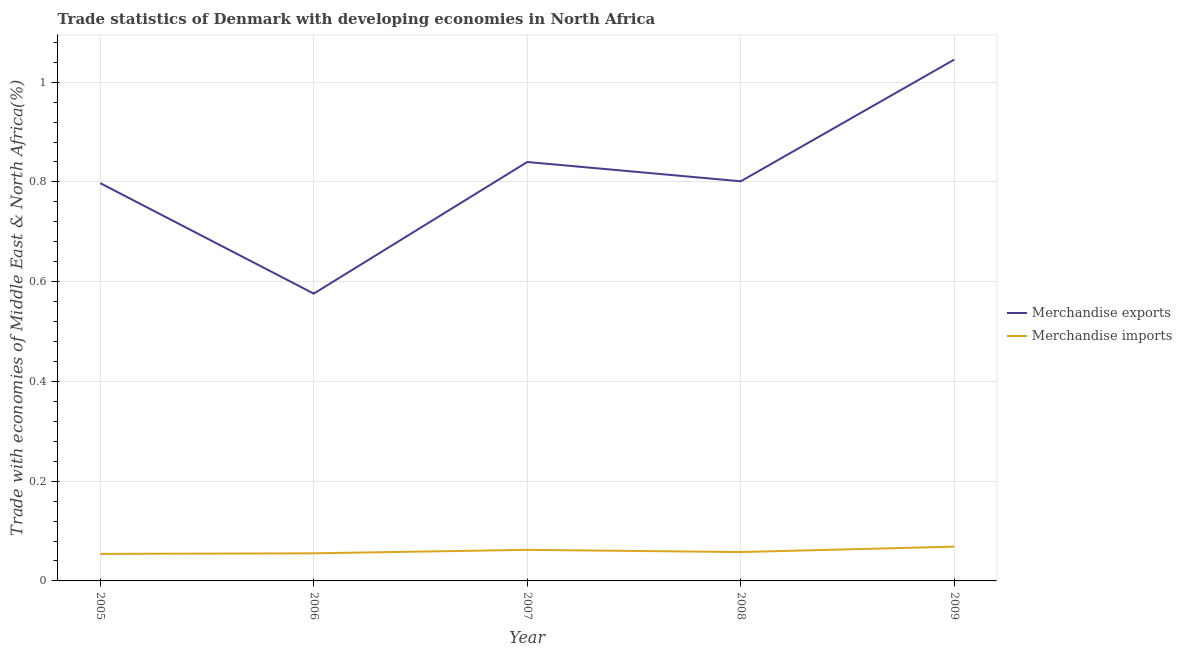Is the number of lines equal to the number of legend labels?
Offer a terse response. Yes. What is the merchandise exports in 2008?
Offer a very short reply. 0.8. Across all years, what is the maximum merchandise imports?
Give a very brief answer. 0.07. Across all years, what is the minimum merchandise imports?
Ensure brevity in your answer.  0.05. In which year was the merchandise imports minimum?
Keep it short and to the point. 2005. What is the total merchandise exports in the graph?
Keep it short and to the point. 4.06. What is the difference between the merchandise exports in 2007 and that in 2008?
Offer a very short reply. 0.04. What is the difference between the merchandise imports in 2007 and the merchandise exports in 2006?
Provide a succinct answer. -0.51. What is the average merchandise imports per year?
Offer a terse response. 0.06. In the year 2008, what is the difference between the merchandise exports and merchandise imports?
Provide a succinct answer. 0.74. In how many years, is the merchandise imports greater than 0.48000000000000004 %?
Give a very brief answer. 0. What is the ratio of the merchandise exports in 2006 to that in 2008?
Keep it short and to the point. 0.72. Is the merchandise exports in 2006 less than that in 2009?
Keep it short and to the point. Yes. Is the difference between the merchandise exports in 2005 and 2006 greater than the difference between the merchandise imports in 2005 and 2006?
Provide a succinct answer. Yes. What is the difference between the highest and the second highest merchandise exports?
Provide a short and direct response. 0.21. What is the difference between the highest and the lowest merchandise imports?
Your answer should be compact. 0.01. In how many years, is the merchandise imports greater than the average merchandise imports taken over all years?
Your answer should be compact. 2. Is the sum of the merchandise imports in 2007 and 2009 greater than the maximum merchandise exports across all years?
Keep it short and to the point. No. Is the merchandise imports strictly less than the merchandise exports over the years?
Your response must be concise. Yes. How many years are there in the graph?
Provide a succinct answer. 5. What is the difference between two consecutive major ticks on the Y-axis?
Provide a short and direct response. 0.2. What is the title of the graph?
Ensure brevity in your answer.  Trade statistics of Denmark with developing economies in North Africa. What is the label or title of the X-axis?
Offer a very short reply. Year. What is the label or title of the Y-axis?
Your response must be concise. Trade with economies of Middle East & North Africa(%). What is the Trade with economies of Middle East & North Africa(%) of Merchandise exports in 2005?
Make the answer very short. 0.8. What is the Trade with economies of Middle East & North Africa(%) of Merchandise imports in 2005?
Your answer should be very brief. 0.05. What is the Trade with economies of Middle East & North Africa(%) in Merchandise exports in 2006?
Provide a short and direct response. 0.58. What is the Trade with economies of Middle East & North Africa(%) in Merchandise imports in 2006?
Ensure brevity in your answer.  0.06. What is the Trade with economies of Middle East & North Africa(%) in Merchandise exports in 2007?
Offer a terse response. 0.84. What is the Trade with economies of Middle East & North Africa(%) of Merchandise imports in 2007?
Ensure brevity in your answer.  0.06. What is the Trade with economies of Middle East & North Africa(%) in Merchandise exports in 2008?
Offer a very short reply. 0.8. What is the Trade with economies of Middle East & North Africa(%) of Merchandise imports in 2008?
Provide a succinct answer. 0.06. What is the Trade with economies of Middle East & North Africa(%) in Merchandise exports in 2009?
Give a very brief answer. 1.05. What is the Trade with economies of Middle East & North Africa(%) of Merchandise imports in 2009?
Provide a succinct answer. 0.07. Across all years, what is the maximum Trade with economies of Middle East & North Africa(%) in Merchandise exports?
Offer a very short reply. 1.05. Across all years, what is the maximum Trade with economies of Middle East & North Africa(%) of Merchandise imports?
Your answer should be compact. 0.07. Across all years, what is the minimum Trade with economies of Middle East & North Africa(%) of Merchandise exports?
Give a very brief answer. 0.58. Across all years, what is the minimum Trade with economies of Middle East & North Africa(%) of Merchandise imports?
Give a very brief answer. 0.05. What is the total Trade with economies of Middle East & North Africa(%) of Merchandise exports in the graph?
Provide a succinct answer. 4.06. What is the total Trade with economies of Middle East & North Africa(%) of Merchandise imports in the graph?
Ensure brevity in your answer.  0.3. What is the difference between the Trade with economies of Middle East & North Africa(%) of Merchandise exports in 2005 and that in 2006?
Offer a terse response. 0.22. What is the difference between the Trade with economies of Middle East & North Africa(%) in Merchandise imports in 2005 and that in 2006?
Keep it short and to the point. -0. What is the difference between the Trade with economies of Middle East & North Africa(%) in Merchandise exports in 2005 and that in 2007?
Offer a terse response. -0.04. What is the difference between the Trade with economies of Middle East & North Africa(%) in Merchandise imports in 2005 and that in 2007?
Offer a very short reply. -0.01. What is the difference between the Trade with economies of Middle East & North Africa(%) in Merchandise exports in 2005 and that in 2008?
Your answer should be compact. -0. What is the difference between the Trade with economies of Middle East & North Africa(%) in Merchandise imports in 2005 and that in 2008?
Your answer should be very brief. -0. What is the difference between the Trade with economies of Middle East & North Africa(%) in Merchandise exports in 2005 and that in 2009?
Provide a short and direct response. -0.25. What is the difference between the Trade with economies of Middle East & North Africa(%) of Merchandise imports in 2005 and that in 2009?
Provide a succinct answer. -0.01. What is the difference between the Trade with economies of Middle East & North Africa(%) in Merchandise exports in 2006 and that in 2007?
Ensure brevity in your answer.  -0.26. What is the difference between the Trade with economies of Middle East & North Africa(%) of Merchandise imports in 2006 and that in 2007?
Your response must be concise. -0.01. What is the difference between the Trade with economies of Middle East & North Africa(%) of Merchandise exports in 2006 and that in 2008?
Provide a succinct answer. -0.23. What is the difference between the Trade with economies of Middle East & North Africa(%) in Merchandise imports in 2006 and that in 2008?
Make the answer very short. -0. What is the difference between the Trade with economies of Middle East & North Africa(%) of Merchandise exports in 2006 and that in 2009?
Offer a terse response. -0.47. What is the difference between the Trade with economies of Middle East & North Africa(%) in Merchandise imports in 2006 and that in 2009?
Ensure brevity in your answer.  -0.01. What is the difference between the Trade with economies of Middle East & North Africa(%) of Merchandise exports in 2007 and that in 2008?
Your response must be concise. 0.04. What is the difference between the Trade with economies of Middle East & North Africa(%) of Merchandise imports in 2007 and that in 2008?
Your answer should be very brief. 0. What is the difference between the Trade with economies of Middle East & North Africa(%) of Merchandise exports in 2007 and that in 2009?
Give a very brief answer. -0.21. What is the difference between the Trade with economies of Middle East & North Africa(%) of Merchandise imports in 2007 and that in 2009?
Ensure brevity in your answer.  -0.01. What is the difference between the Trade with economies of Middle East & North Africa(%) of Merchandise exports in 2008 and that in 2009?
Ensure brevity in your answer.  -0.24. What is the difference between the Trade with economies of Middle East & North Africa(%) of Merchandise imports in 2008 and that in 2009?
Offer a terse response. -0.01. What is the difference between the Trade with economies of Middle East & North Africa(%) of Merchandise exports in 2005 and the Trade with economies of Middle East & North Africa(%) of Merchandise imports in 2006?
Ensure brevity in your answer.  0.74. What is the difference between the Trade with economies of Middle East & North Africa(%) in Merchandise exports in 2005 and the Trade with economies of Middle East & North Africa(%) in Merchandise imports in 2007?
Your response must be concise. 0.74. What is the difference between the Trade with economies of Middle East & North Africa(%) in Merchandise exports in 2005 and the Trade with economies of Middle East & North Africa(%) in Merchandise imports in 2008?
Give a very brief answer. 0.74. What is the difference between the Trade with economies of Middle East & North Africa(%) of Merchandise exports in 2005 and the Trade with economies of Middle East & North Africa(%) of Merchandise imports in 2009?
Offer a terse response. 0.73. What is the difference between the Trade with economies of Middle East & North Africa(%) of Merchandise exports in 2006 and the Trade with economies of Middle East & North Africa(%) of Merchandise imports in 2007?
Your answer should be very brief. 0.51. What is the difference between the Trade with economies of Middle East & North Africa(%) of Merchandise exports in 2006 and the Trade with economies of Middle East & North Africa(%) of Merchandise imports in 2008?
Offer a terse response. 0.52. What is the difference between the Trade with economies of Middle East & North Africa(%) of Merchandise exports in 2006 and the Trade with economies of Middle East & North Africa(%) of Merchandise imports in 2009?
Provide a short and direct response. 0.51. What is the difference between the Trade with economies of Middle East & North Africa(%) in Merchandise exports in 2007 and the Trade with economies of Middle East & North Africa(%) in Merchandise imports in 2008?
Offer a very short reply. 0.78. What is the difference between the Trade with economies of Middle East & North Africa(%) in Merchandise exports in 2007 and the Trade with economies of Middle East & North Africa(%) in Merchandise imports in 2009?
Offer a terse response. 0.77. What is the difference between the Trade with economies of Middle East & North Africa(%) in Merchandise exports in 2008 and the Trade with economies of Middle East & North Africa(%) in Merchandise imports in 2009?
Make the answer very short. 0.73. What is the average Trade with economies of Middle East & North Africa(%) in Merchandise exports per year?
Give a very brief answer. 0.81. What is the average Trade with economies of Middle East & North Africa(%) in Merchandise imports per year?
Your answer should be compact. 0.06. In the year 2005, what is the difference between the Trade with economies of Middle East & North Africa(%) of Merchandise exports and Trade with economies of Middle East & North Africa(%) of Merchandise imports?
Give a very brief answer. 0.74. In the year 2006, what is the difference between the Trade with economies of Middle East & North Africa(%) of Merchandise exports and Trade with economies of Middle East & North Africa(%) of Merchandise imports?
Ensure brevity in your answer.  0.52. In the year 2007, what is the difference between the Trade with economies of Middle East & North Africa(%) in Merchandise exports and Trade with economies of Middle East & North Africa(%) in Merchandise imports?
Give a very brief answer. 0.78. In the year 2008, what is the difference between the Trade with economies of Middle East & North Africa(%) in Merchandise exports and Trade with economies of Middle East & North Africa(%) in Merchandise imports?
Provide a short and direct response. 0.74. In the year 2009, what is the difference between the Trade with economies of Middle East & North Africa(%) in Merchandise exports and Trade with economies of Middle East & North Africa(%) in Merchandise imports?
Ensure brevity in your answer.  0.98. What is the ratio of the Trade with economies of Middle East & North Africa(%) of Merchandise exports in 2005 to that in 2006?
Give a very brief answer. 1.38. What is the ratio of the Trade with economies of Middle East & North Africa(%) of Merchandise imports in 2005 to that in 2006?
Your answer should be compact. 0.98. What is the ratio of the Trade with economies of Middle East & North Africa(%) of Merchandise exports in 2005 to that in 2007?
Offer a very short reply. 0.95. What is the ratio of the Trade with economies of Middle East & North Africa(%) of Merchandise imports in 2005 to that in 2007?
Offer a terse response. 0.87. What is the ratio of the Trade with economies of Middle East & North Africa(%) in Merchandise imports in 2005 to that in 2008?
Ensure brevity in your answer.  0.94. What is the ratio of the Trade with economies of Middle East & North Africa(%) of Merchandise exports in 2005 to that in 2009?
Provide a short and direct response. 0.76. What is the ratio of the Trade with economies of Middle East & North Africa(%) in Merchandise imports in 2005 to that in 2009?
Offer a terse response. 0.79. What is the ratio of the Trade with economies of Middle East & North Africa(%) in Merchandise exports in 2006 to that in 2007?
Your answer should be compact. 0.69. What is the ratio of the Trade with economies of Middle East & North Africa(%) of Merchandise imports in 2006 to that in 2007?
Give a very brief answer. 0.89. What is the ratio of the Trade with economies of Middle East & North Africa(%) of Merchandise exports in 2006 to that in 2008?
Provide a succinct answer. 0.72. What is the ratio of the Trade with economies of Middle East & North Africa(%) of Merchandise imports in 2006 to that in 2008?
Offer a terse response. 0.96. What is the ratio of the Trade with economies of Middle East & North Africa(%) of Merchandise exports in 2006 to that in 2009?
Provide a short and direct response. 0.55. What is the ratio of the Trade with economies of Middle East & North Africa(%) of Merchandise imports in 2006 to that in 2009?
Offer a very short reply. 0.81. What is the ratio of the Trade with economies of Middle East & North Africa(%) of Merchandise exports in 2007 to that in 2008?
Your answer should be very brief. 1.05. What is the ratio of the Trade with economies of Middle East & North Africa(%) in Merchandise imports in 2007 to that in 2008?
Your answer should be compact. 1.08. What is the ratio of the Trade with economies of Middle East & North Africa(%) in Merchandise exports in 2007 to that in 2009?
Your response must be concise. 0.8. What is the ratio of the Trade with economies of Middle East & North Africa(%) of Merchandise imports in 2007 to that in 2009?
Provide a succinct answer. 0.91. What is the ratio of the Trade with economies of Middle East & North Africa(%) of Merchandise exports in 2008 to that in 2009?
Your response must be concise. 0.77. What is the ratio of the Trade with economies of Middle East & North Africa(%) of Merchandise imports in 2008 to that in 2009?
Your answer should be very brief. 0.84. What is the difference between the highest and the second highest Trade with economies of Middle East & North Africa(%) of Merchandise exports?
Ensure brevity in your answer.  0.21. What is the difference between the highest and the second highest Trade with economies of Middle East & North Africa(%) of Merchandise imports?
Your answer should be very brief. 0.01. What is the difference between the highest and the lowest Trade with economies of Middle East & North Africa(%) in Merchandise exports?
Make the answer very short. 0.47. What is the difference between the highest and the lowest Trade with economies of Middle East & North Africa(%) in Merchandise imports?
Ensure brevity in your answer.  0.01. 